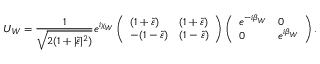Convert formula to latex. <formula><loc_0><loc_0><loc_500><loc_500>U _ { W } = \frac { 1 } { \sqrt { 2 ( 1 + | \tilde { \varepsilon } | ^ { 2 } ) } } e ^ { i \chi _ { W } } \left ( \begin{array} { l l } { { ( 1 + \tilde { \varepsilon } ) } } & { { ( 1 + \tilde { \varepsilon } ) } } \\ { { - ( 1 - \tilde { \varepsilon } ) } } & { { ( 1 - \tilde { \varepsilon } ) } } \end{array} \right ) \left ( \begin{array} { l l } { { e ^ { - i \beta _ { W } } } } & { 0 } \\ { 0 } & { { e ^ { i \beta _ { W } } } } \end{array} \right ) .</formula> 